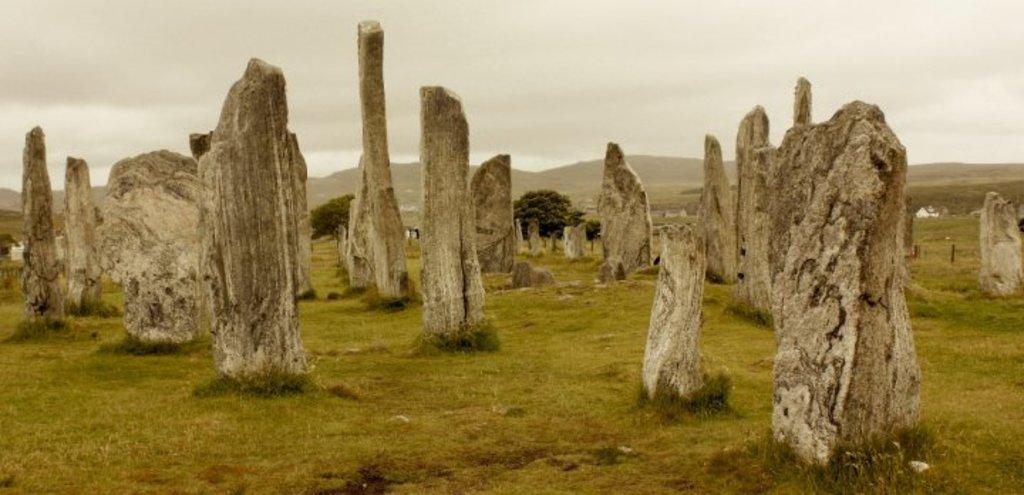What type of natural features can be seen on the ground in the image? There are rocks on the ground in the image. What type of vegetation is visible in the background of the image? There are trees in the background of the image. What type of large landforms are visible in the background of the image? There are mountains in the background of the image. What is visible above the mountains in the image? The sky is visible in the background of the image. What type of frame is used to display the image? The provided facts do not mention any frame, so we cannot determine the type of frame used to display the image. Can you hear the voice of the person who took the image? The provided facts do not mention any person taking the image or any voice, so we cannot determine if a voice is present. 